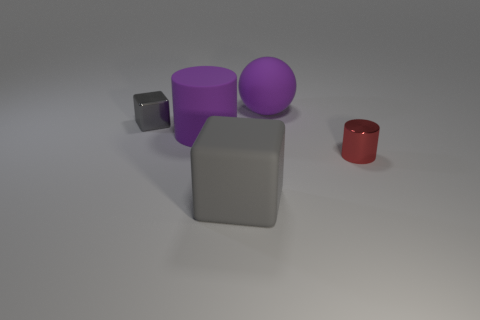Is the color of the tiny metal thing that is behind the small cylinder the same as the big rubber thing in front of the purple cylinder?
Your response must be concise. Yes. How many gray objects are to the left of the large purple thing on the left side of the large gray cube?
Your answer should be very brief. 1. Is there a gray matte cylinder?
Provide a succinct answer. No. How many other things are there of the same color as the large matte cube?
Provide a short and direct response. 1. Are there fewer large brown shiny spheres than gray shiny cubes?
Ensure brevity in your answer.  Yes. There is a gray object to the left of the cube in front of the metallic block; what shape is it?
Offer a very short reply. Cube. There is a rubber cylinder; are there any small shiny things on the left side of it?
Provide a short and direct response. Yes. What is the color of the metal cube that is the same size as the red cylinder?
Your response must be concise. Gray. How many purple cylinders are the same material as the big ball?
Offer a terse response. 1. How many other objects are there of the same size as the metallic cylinder?
Provide a short and direct response. 1. 